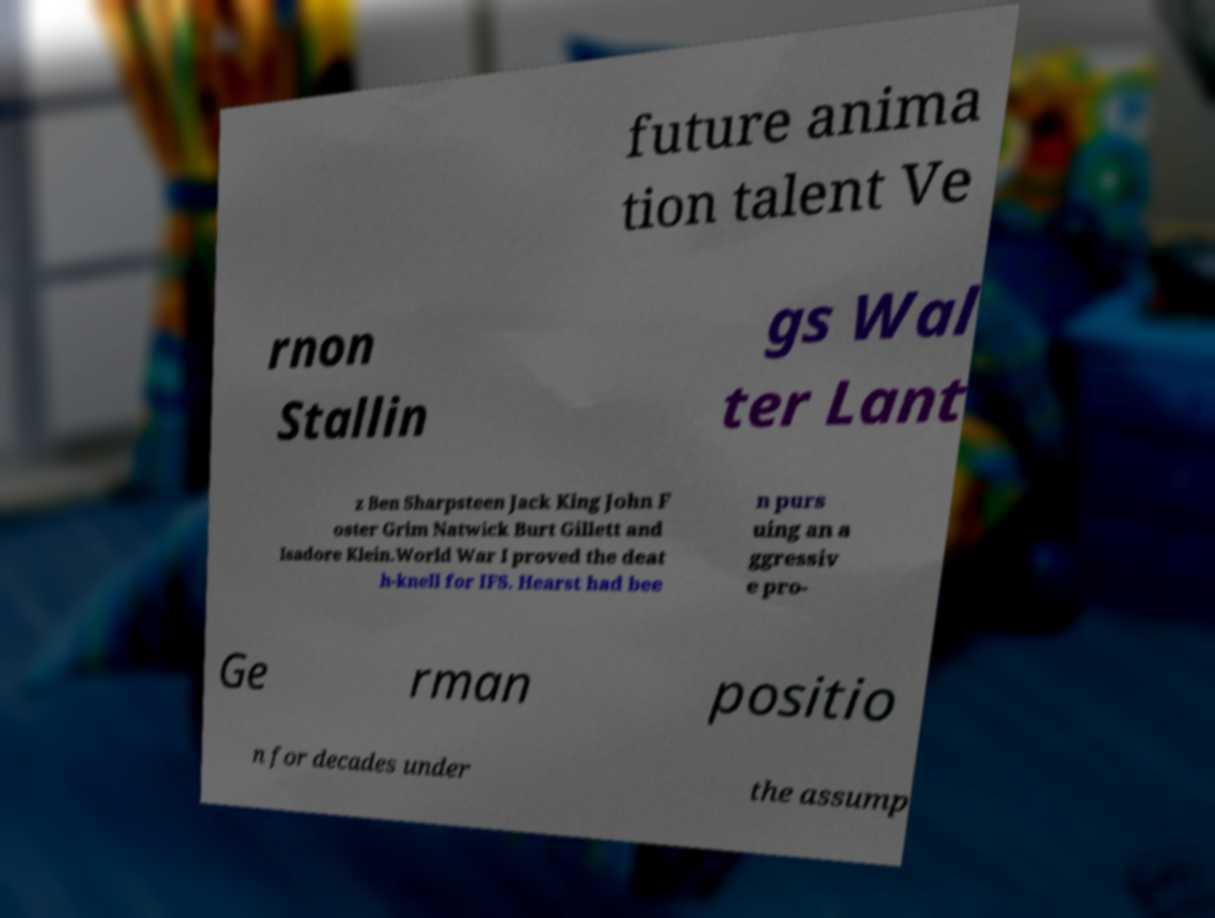Could you assist in decoding the text presented in this image and type it out clearly? future anima tion talent Ve rnon Stallin gs Wal ter Lant z Ben Sharpsteen Jack King John F oster Grim Natwick Burt Gillett and Isadore Klein.World War I proved the deat h-knell for IFS. Hearst had bee n purs uing an a ggressiv e pro- Ge rman positio n for decades under the assump 